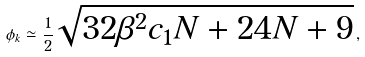Convert formula to latex. <formula><loc_0><loc_0><loc_500><loc_500>\phi _ { k } \simeq \frac { 1 } { 2 } \sqrt { 3 2 \beta ^ { 2 } c _ { 1 } N + 2 4 N + 9 } \, ,</formula> 